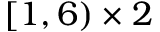Convert formula to latex. <formula><loc_0><loc_0><loc_500><loc_500>[ 1 , 6 ) \times 2</formula> 